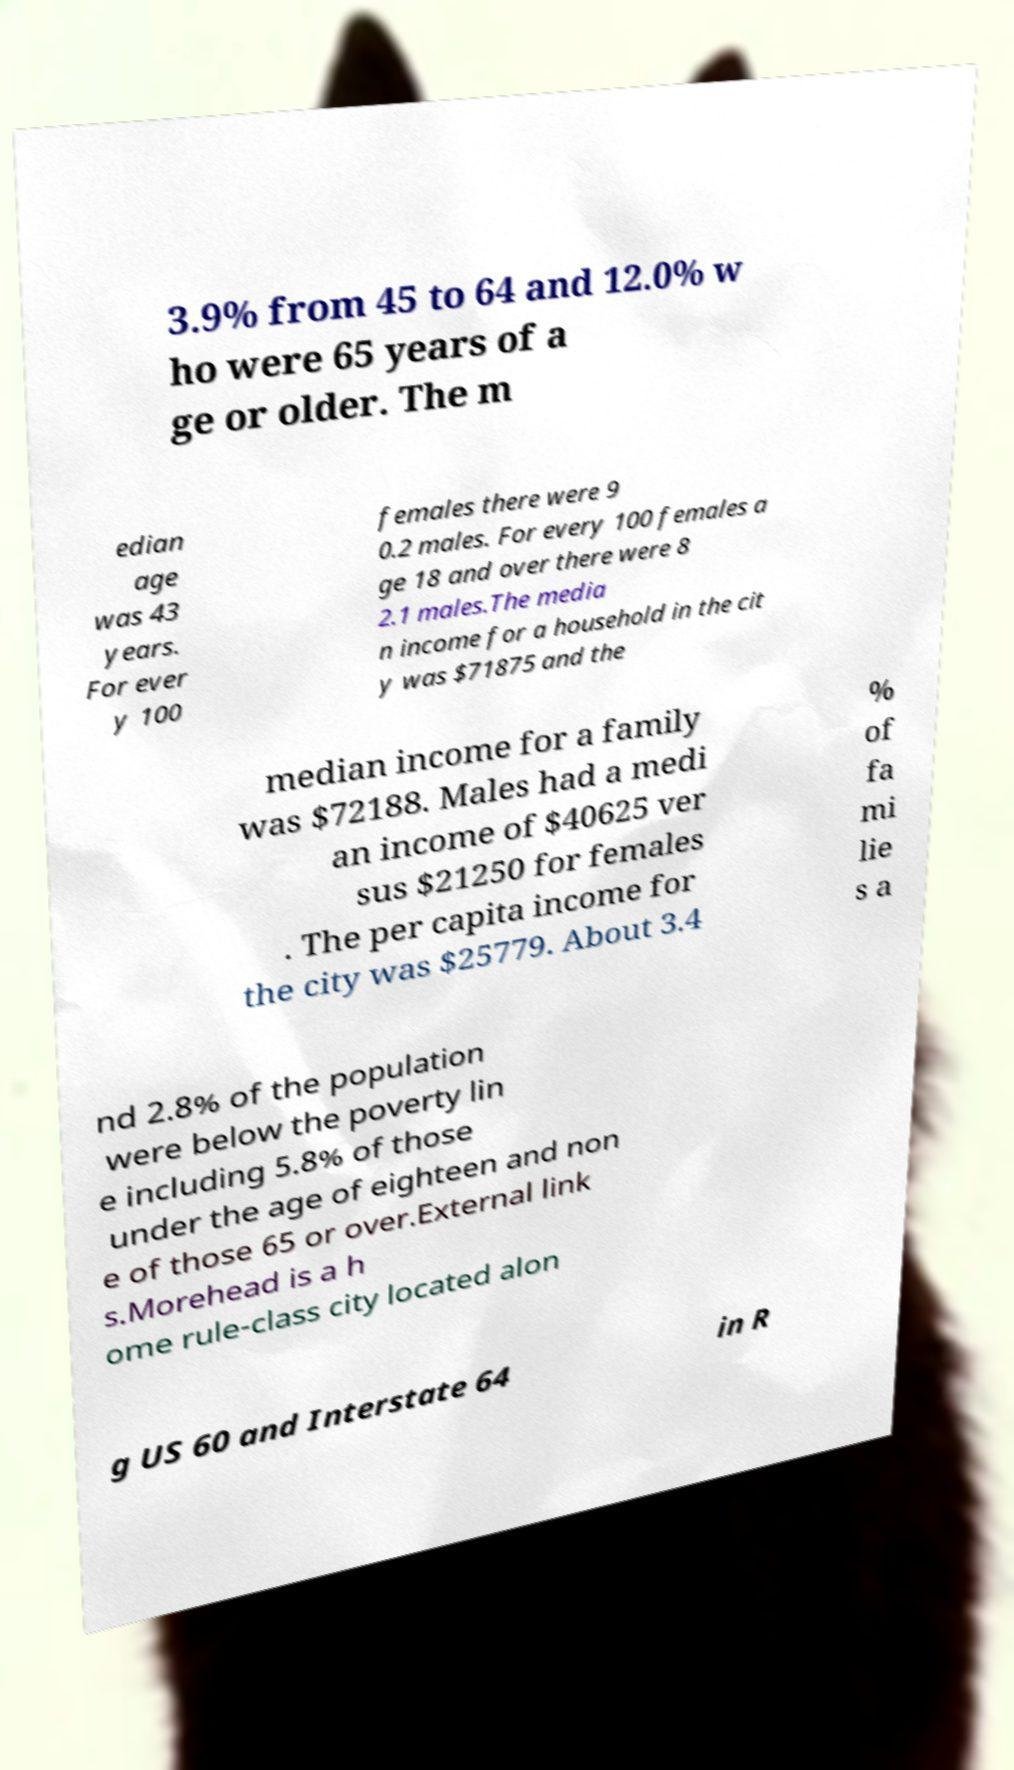Please identify and transcribe the text found in this image. 3.9% from 45 to 64 and 12.0% w ho were 65 years of a ge or older. The m edian age was 43 years. For ever y 100 females there were 9 0.2 males. For every 100 females a ge 18 and over there were 8 2.1 males.The media n income for a household in the cit y was $71875 and the median income for a family was $72188. Males had a medi an income of $40625 ver sus $21250 for females . The per capita income for the city was $25779. About 3.4 % of fa mi lie s a nd 2.8% of the population were below the poverty lin e including 5.8% of those under the age of eighteen and non e of those 65 or over.External link s.Morehead is a h ome rule-class city located alon g US 60 and Interstate 64 in R 